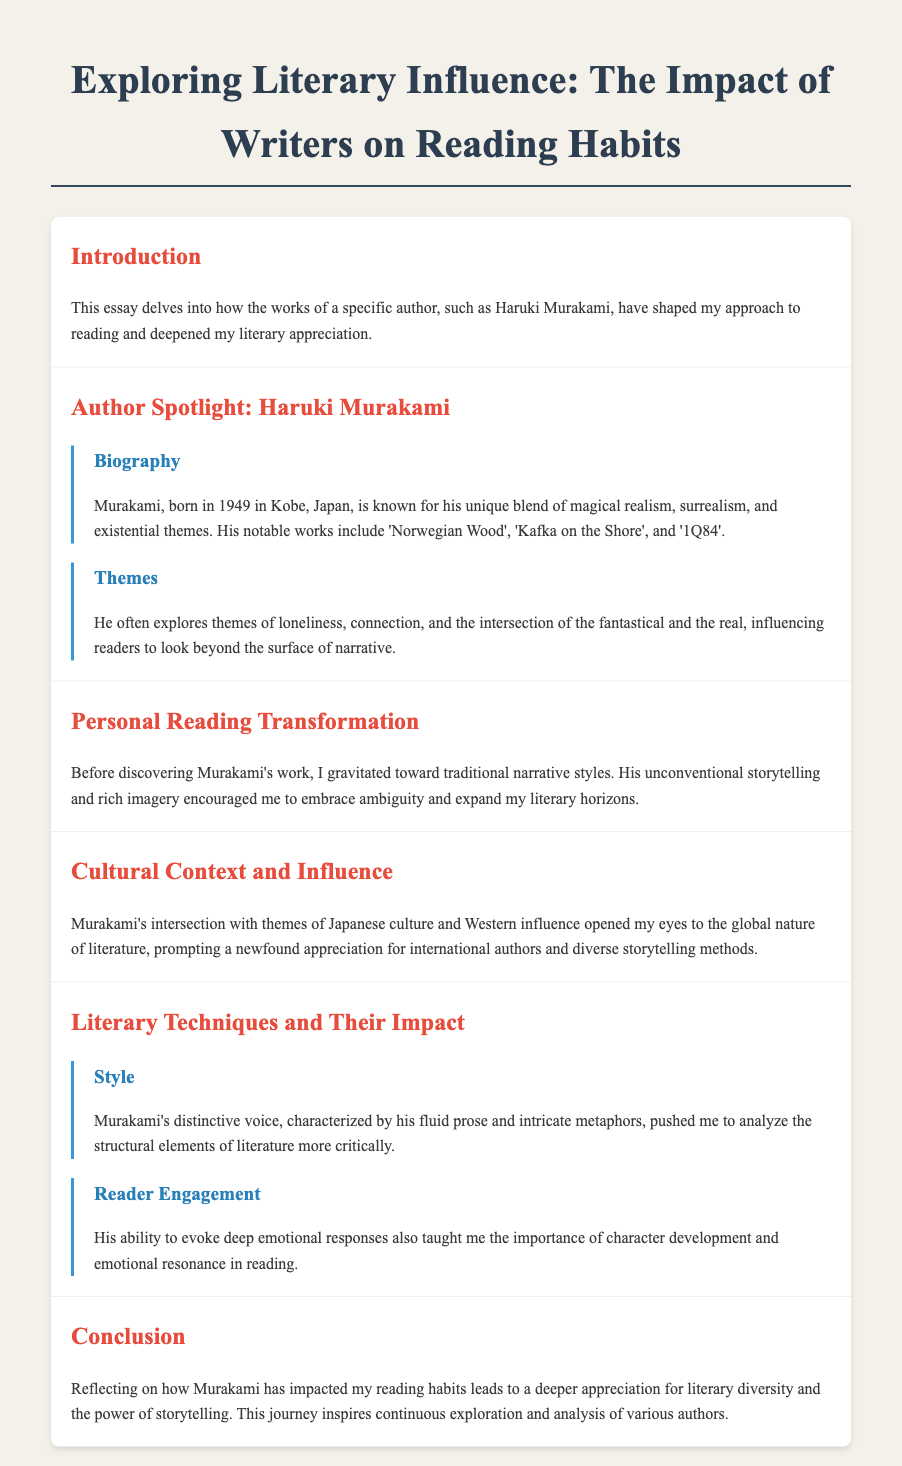What is the title of the essay? The title is found in the header of the document and introduces the main subject of the essay.
Answer: Exploring Literary Influence: The Impact of Writers on Reading Habits Who is the author spotlighted in the essay? The author spotlighted is specified in the section dedicated to exploring the biography and influence of a specific writer.
Answer: Haruki Murakami What year was Haruki Murakami born? The birth year of Murakami is mentioned in his biography section.
Answer: 1949 Name one notable work of Haruki Murakami. A notable work is listed in the biography and showcases the author's significant contributions.
Answer: Norwegian Wood What major theme does Murakami often explore? A key theme is described and highlights the depth of his literary exploration.
Answer: Loneliness How did Murakami influence the author's reading style? The transformation in the author's reading habits is discussed and connects to their growth as a reader.
Answer: Embrace ambiguity What impact did Murakami's works have on the author's appreciation of literature? The conclusion reflects on the broader understanding and respect for literary diversity that arose from this influence.
Answer: Literary diversity Name one literary technique discussed in the essay. The essay mentions specific techniques that impacted the author's analysis of literature.
Answer: Fluid prose What does the author believe is key to reader engagement? This important aspect is highlighted in the section discussing engagement through Murakami's work.
Answer: Character development 